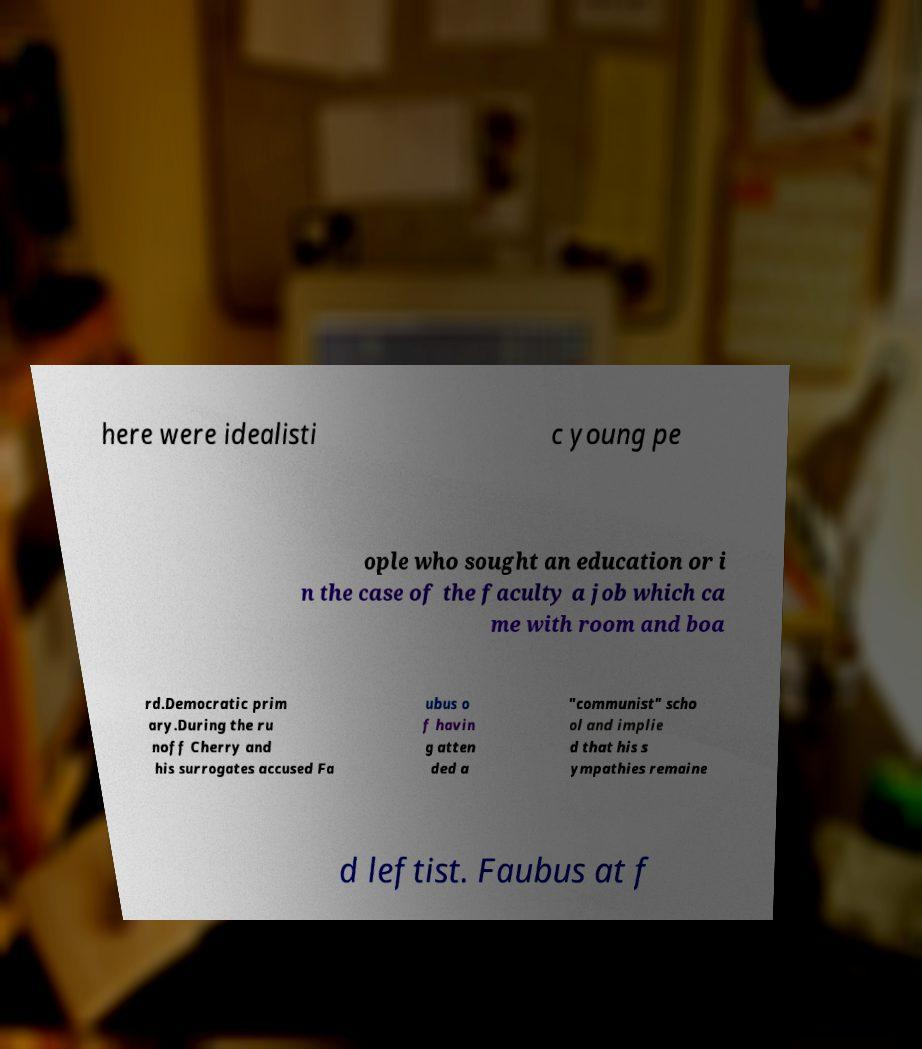I need the written content from this picture converted into text. Can you do that? here were idealisti c young pe ople who sought an education or i n the case of the faculty a job which ca me with room and boa rd.Democratic prim ary.During the ru noff Cherry and his surrogates accused Fa ubus o f havin g atten ded a "communist" scho ol and implie d that his s ympathies remaine d leftist. Faubus at f 